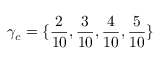<formula> <loc_0><loc_0><loc_500><loc_500>\gamma _ { c } = \{ \frac { 2 } { 1 0 } , \frac { 3 } { 1 0 } , \frac { 4 } { 1 0 } , \frac { 5 } { 1 0 } \}</formula> 